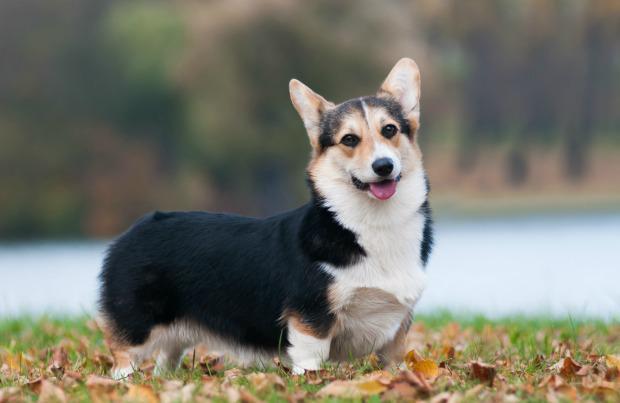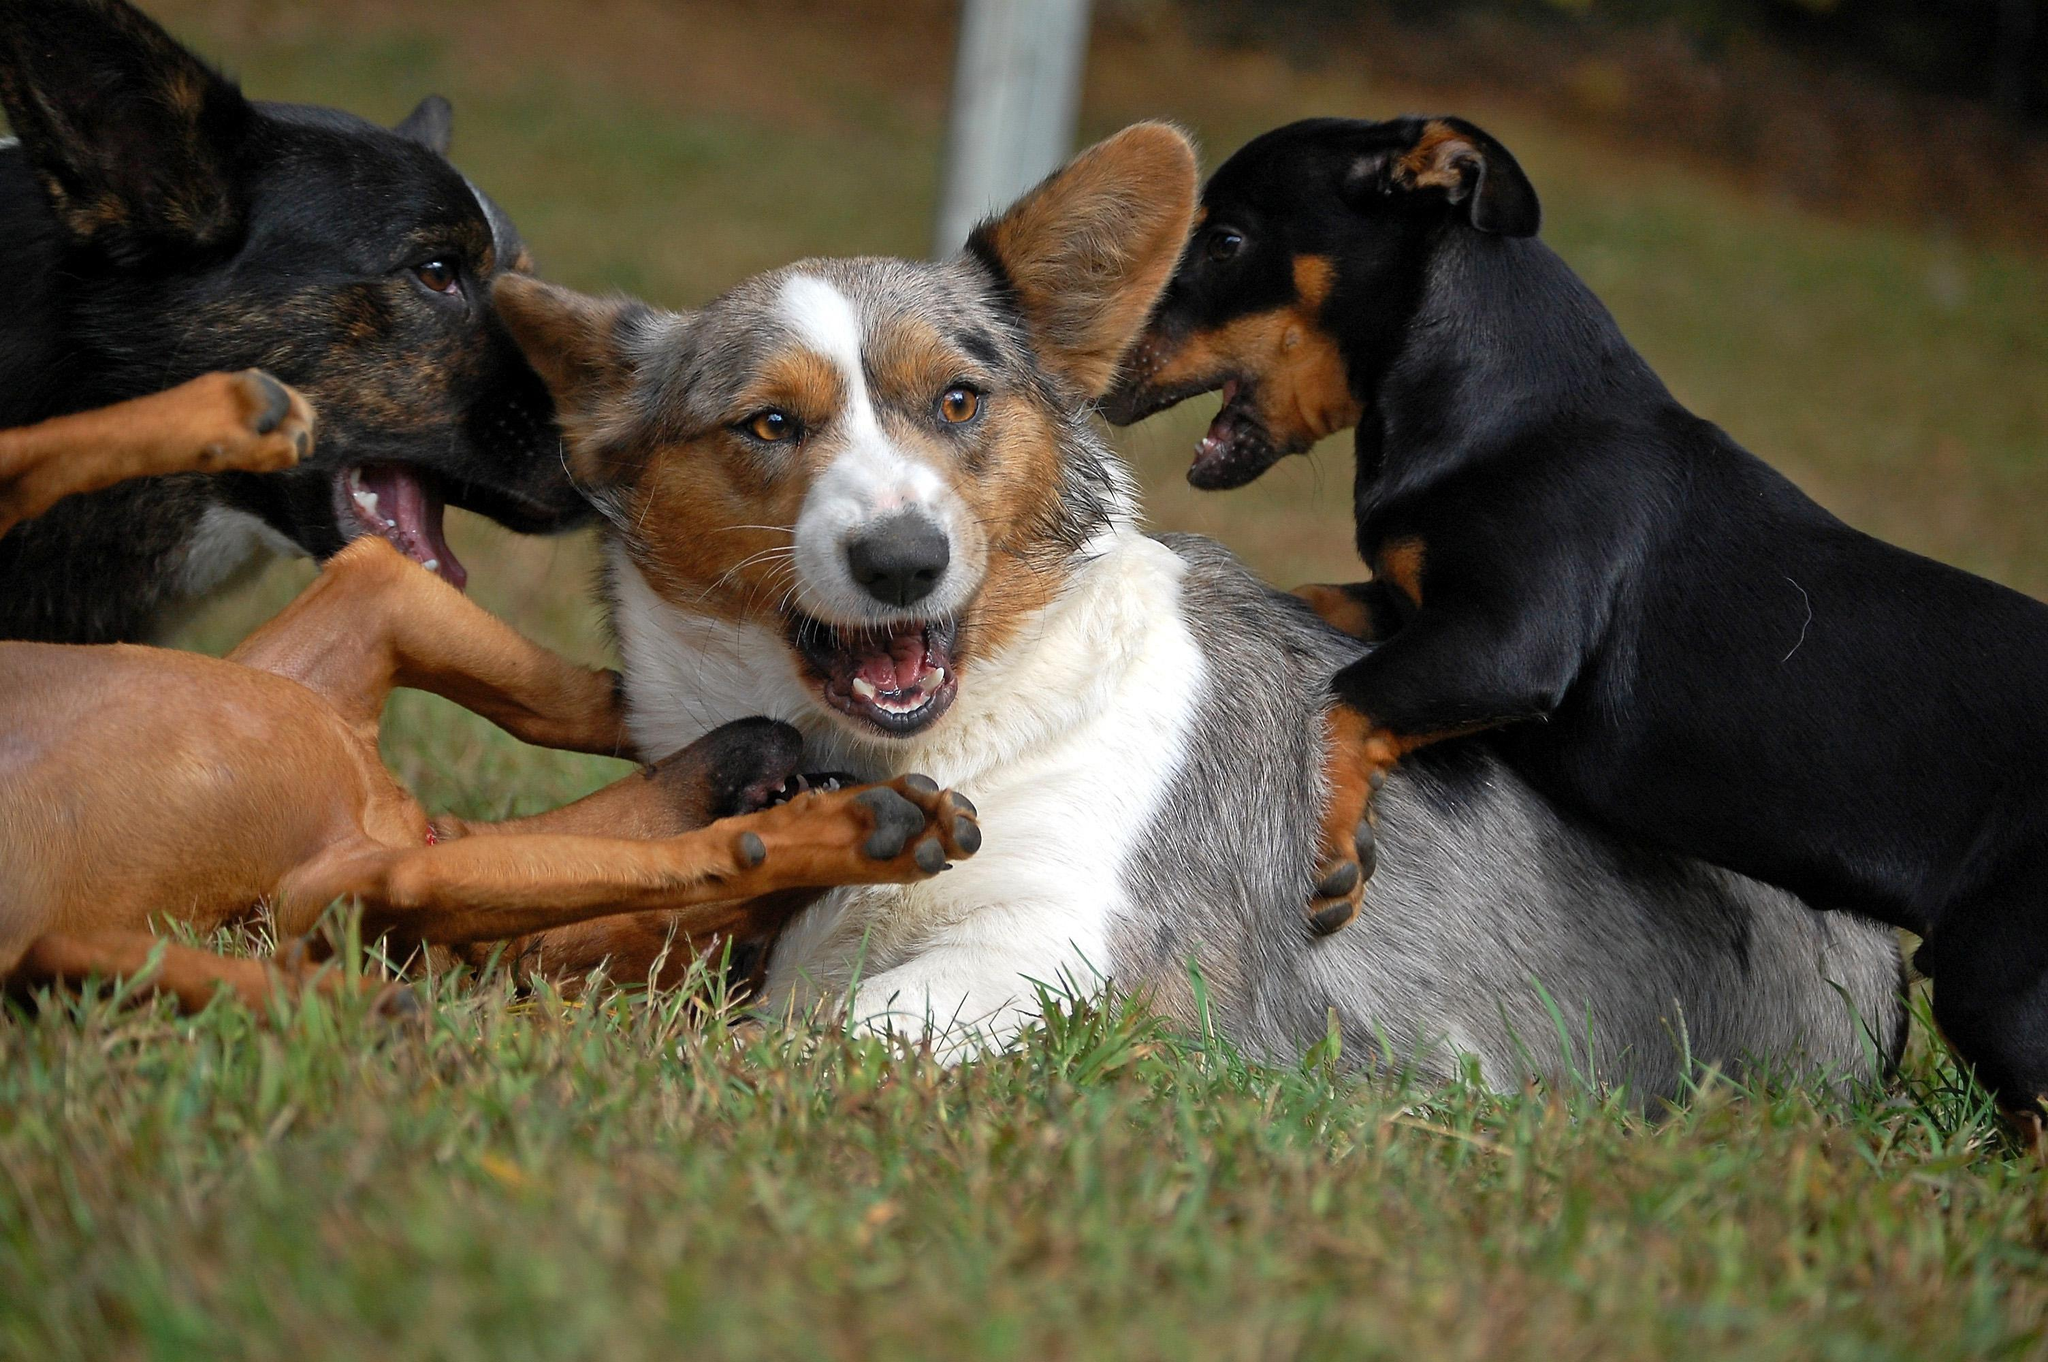The first image is the image on the left, the second image is the image on the right. For the images displayed, is the sentence "All the dogs are facing right in the right image." factually correct? Answer yes or no. No. 